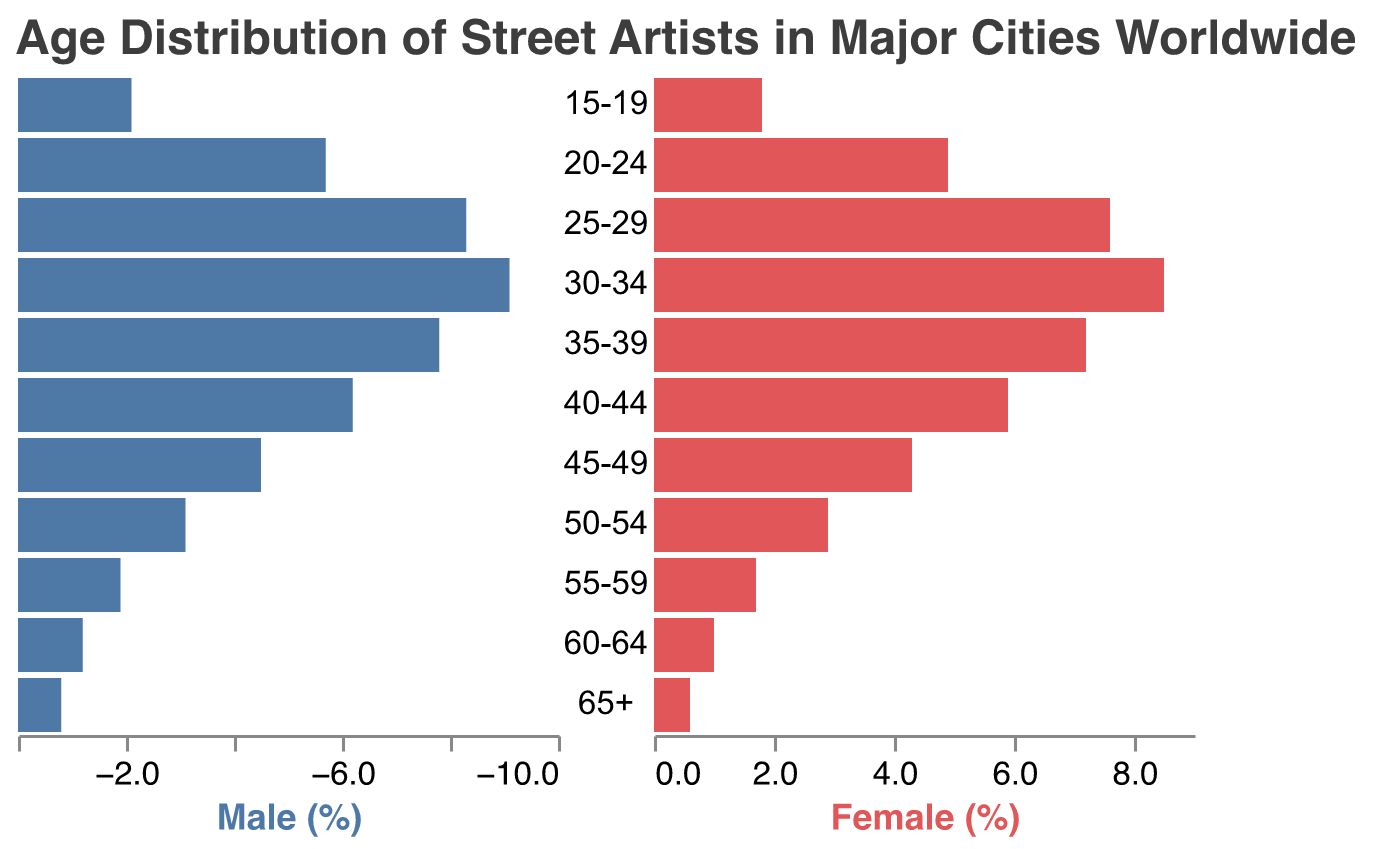What age group has the highest percentage of male street artists? To find the age group with the highest percentage of male street artists, look at the bar corresponding to the 'Male' section. Observe that the highest value is 9.1% for the age group 30-34.
Answer: 30-34 What is the title of the plot? The title of the plot is displayed at the top, indicating what the entire plot represents: "Age Distribution of Street Artists in Major Cities Worldwide."
Answer: Age Distribution of Street Artists in Major Cities Worldwide What's the combined percentage of male and female street artists aged 25-29? Identify the percentage of males (8.3) and females (7.6) for the age group 25-29, respectively. Sum these values to get the combined percentage: 8.3 + 7.6 = 15.9%.
Answer: 15.9% What colors represent the male and female artists in the plot? Observe the bars representing male and female sections. The male bars are colored in blue (#4E79A7), and the female bars are in red (#E15759).
Answer: Male: Blue, Female: Red How does the percentage of female street artists aged 20-24 compare to those aged 35-39? Compare the heights of the bars for females aged 20-24 (4.9%) and 35-39 (7.2%). Notice that the percentage for 35-39 is higher than that for 20-24.
Answer: 35-39 is higher What is the percentage difference between male and female street artists in the 60-64 age group? Identify the values for males (1.2) and females (1.0) in the 60-64 age group. Calculate the difference: 1.2 - 1 = 0.2.
Answer: 0.2% Which age group has the smallest percentage of female street artists? Look for the smallest bar on the female side. The smallest value is 0.6% for the age group 65+.
Answer: 65+ Is there an age group where the percentage of male street artists is less than 2%? If so, which one(s)? Search for any male bars with values less than 2%. The only age group that fits this criterion is 65+ with 0.8%.
Answer: 65+ What age groups have a higher percentage of male street artists compared to female street artists in the same group? Compare male and female bars for each age group. Age groups where male percentages are higher than female percentages: 15-19, 20-24, 25-29, 30-34, 35-39, 40-44, 45-49, 50-54, 55-59, 60-64, and 65+. All age groups.
Answer: All age groups 